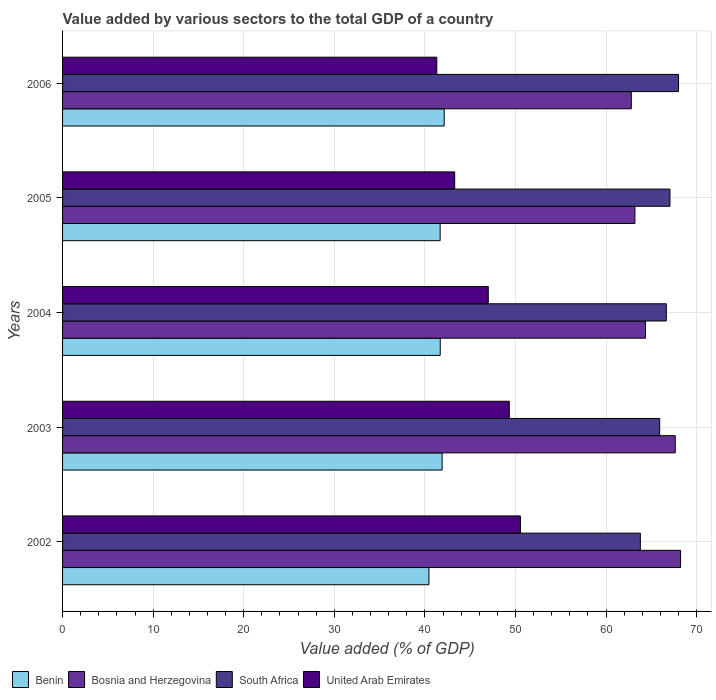How many groups of bars are there?
Offer a terse response. 5. Are the number of bars per tick equal to the number of legend labels?
Your answer should be very brief. Yes. How many bars are there on the 2nd tick from the top?
Provide a succinct answer. 4. In how many cases, is the number of bars for a given year not equal to the number of legend labels?
Provide a succinct answer. 0. What is the value added by various sectors to the total GDP in Benin in 2004?
Your response must be concise. 41.69. Across all years, what is the maximum value added by various sectors to the total GDP in Benin?
Give a very brief answer. 42.13. Across all years, what is the minimum value added by various sectors to the total GDP in United Arab Emirates?
Your answer should be compact. 41.32. In which year was the value added by various sectors to the total GDP in United Arab Emirates maximum?
Make the answer very short. 2002. In which year was the value added by various sectors to the total GDP in Bosnia and Herzegovina minimum?
Give a very brief answer. 2006. What is the total value added by various sectors to the total GDP in United Arab Emirates in the graph?
Make the answer very short. 231.48. What is the difference between the value added by various sectors to the total GDP in United Arab Emirates in 2002 and that in 2004?
Provide a short and direct response. 3.56. What is the difference between the value added by various sectors to the total GDP in Benin in 2006 and the value added by various sectors to the total GDP in Bosnia and Herzegovina in 2005?
Offer a very short reply. -21.05. What is the average value added by various sectors to the total GDP in United Arab Emirates per year?
Offer a terse response. 46.3. In the year 2005, what is the difference between the value added by various sectors to the total GDP in Bosnia and Herzegovina and value added by various sectors to the total GDP in South Africa?
Provide a succinct answer. -3.87. In how many years, is the value added by various sectors to the total GDP in Benin greater than 44 %?
Provide a succinct answer. 0. What is the ratio of the value added by various sectors to the total GDP in Benin in 2003 to that in 2006?
Your response must be concise. 0.99. Is the value added by various sectors to the total GDP in South Africa in 2002 less than that in 2004?
Your response must be concise. Yes. What is the difference between the highest and the second highest value added by various sectors to the total GDP in Benin?
Give a very brief answer. 0.23. What is the difference between the highest and the lowest value added by various sectors to the total GDP in Bosnia and Herzegovina?
Offer a very short reply. 5.44. In how many years, is the value added by various sectors to the total GDP in United Arab Emirates greater than the average value added by various sectors to the total GDP in United Arab Emirates taken over all years?
Provide a short and direct response. 3. What does the 1st bar from the top in 2004 represents?
Your response must be concise. United Arab Emirates. What does the 4th bar from the bottom in 2002 represents?
Offer a very short reply. United Arab Emirates. How many bars are there?
Keep it short and to the point. 20. Are all the bars in the graph horizontal?
Your response must be concise. Yes. How many years are there in the graph?
Provide a short and direct response. 5. What is the difference between two consecutive major ticks on the X-axis?
Make the answer very short. 10. Does the graph contain grids?
Give a very brief answer. Yes. Where does the legend appear in the graph?
Your answer should be compact. Bottom left. How many legend labels are there?
Offer a very short reply. 4. What is the title of the graph?
Offer a terse response. Value added by various sectors to the total GDP of a country. Does "Paraguay" appear as one of the legend labels in the graph?
Your response must be concise. No. What is the label or title of the X-axis?
Ensure brevity in your answer.  Value added (% of GDP). What is the label or title of the Y-axis?
Offer a very short reply. Years. What is the Value added (% of GDP) of Benin in 2002?
Ensure brevity in your answer.  40.45. What is the Value added (% of GDP) in Bosnia and Herzegovina in 2002?
Provide a succinct answer. 68.23. What is the Value added (% of GDP) of South Africa in 2002?
Provide a succinct answer. 63.79. What is the Value added (% of GDP) in United Arab Emirates in 2002?
Offer a terse response. 50.56. What is the Value added (% of GDP) in Benin in 2003?
Your answer should be compact. 41.9. What is the Value added (% of GDP) in Bosnia and Herzegovina in 2003?
Ensure brevity in your answer.  67.64. What is the Value added (% of GDP) in South Africa in 2003?
Make the answer very short. 65.92. What is the Value added (% of GDP) in United Arab Emirates in 2003?
Offer a terse response. 49.32. What is the Value added (% of GDP) in Benin in 2004?
Your answer should be very brief. 41.69. What is the Value added (% of GDP) of Bosnia and Herzegovina in 2004?
Provide a succinct answer. 64.35. What is the Value added (% of GDP) of South Africa in 2004?
Your answer should be compact. 66.66. What is the Value added (% of GDP) of United Arab Emirates in 2004?
Offer a very short reply. 47. What is the Value added (% of GDP) of Benin in 2005?
Provide a succinct answer. 41.68. What is the Value added (% of GDP) in Bosnia and Herzegovina in 2005?
Your answer should be compact. 63.19. What is the Value added (% of GDP) in South Africa in 2005?
Ensure brevity in your answer.  67.06. What is the Value added (% of GDP) of United Arab Emirates in 2005?
Give a very brief answer. 43.29. What is the Value added (% of GDP) of Benin in 2006?
Provide a short and direct response. 42.13. What is the Value added (% of GDP) of Bosnia and Herzegovina in 2006?
Ensure brevity in your answer.  62.79. What is the Value added (% of GDP) of South Africa in 2006?
Your answer should be compact. 68. What is the Value added (% of GDP) of United Arab Emirates in 2006?
Your answer should be very brief. 41.32. Across all years, what is the maximum Value added (% of GDP) of Benin?
Provide a succinct answer. 42.13. Across all years, what is the maximum Value added (% of GDP) in Bosnia and Herzegovina?
Ensure brevity in your answer.  68.23. Across all years, what is the maximum Value added (% of GDP) in South Africa?
Provide a short and direct response. 68. Across all years, what is the maximum Value added (% of GDP) in United Arab Emirates?
Offer a very short reply. 50.56. Across all years, what is the minimum Value added (% of GDP) in Benin?
Provide a short and direct response. 40.45. Across all years, what is the minimum Value added (% of GDP) in Bosnia and Herzegovina?
Your answer should be very brief. 62.79. Across all years, what is the minimum Value added (% of GDP) of South Africa?
Ensure brevity in your answer.  63.79. Across all years, what is the minimum Value added (% of GDP) of United Arab Emirates?
Your answer should be compact. 41.32. What is the total Value added (% of GDP) of Benin in the graph?
Keep it short and to the point. 207.86. What is the total Value added (% of GDP) in Bosnia and Herzegovina in the graph?
Provide a succinct answer. 326.2. What is the total Value added (% of GDP) in South Africa in the graph?
Keep it short and to the point. 331.43. What is the total Value added (% of GDP) in United Arab Emirates in the graph?
Your answer should be compact. 231.48. What is the difference between the Value added (% of GDP) in Benin in 2002 and that in 2003?
Your answer should be compact. -1.46. What is the difference between the Value added (% of GDP) of Bosnia and Herzegovina in 2002 and that in 2003?
Provide a succinct answer. 0.59. What is the difference between the Value added (% of GDP) in South Africa in 2002 and that in 2003?
Offer a very short reply. -2.14. What is the difference between the Value added (% of GDP) of United Arab Emirates in 2002 and that in 2003?
Your response must be concise. 1.24. What is the difference between the Value added (% of GDP) of Benin in 2002 and that in 2004?
Provide a short and direct response. -1.25. What is the difference between the Value added (% of GDP) in Bosnia and Herzegovina in 2002 and that in 2004?
Provide a short and direct response. 3.88. What is the difference between the Value added (% of GDP) of South Africa in 2002 and that in 2004?
Keep it short and to the point. -2.87. What is the difference between the Value added (% of GDP) in United Arab Emirates in 2002 and that in 2004?
Your answer should be very brief. 3.56. What is the difference between the Value added (% of GDP) in Benin in 2002 and that in 2005?
Your answer should be very brief. -1.24. What is the difference between the Value added (% of GDP) in Bosnia and Herzegovina in 2002 and that in 2005?
Keep it short and to the point. 5.04. What is the difference between the Value added (% of GDP) of South Africa in 2002 and that in 2005?
Make the answer very short. -3.27. What is the difference between the Value added (% of GDP) in United Arab Emirates in 2002 and that in 2005?
Your answer should be compact. 7.26. What is the difference between the Value added (% of GDP) in Benin in 2002 and that in 2006?
Offer a very short reply. -1.69. What is the difference between the Value added (% of GDP) in Bosnia and Herzegovina in 2002 and that in 2006?
Keep it short and to the point. 5.44. What is the difference between the Value added (% of GDP) of South Africa in 2002 and that in 2006?
Make the answer very short. -4.22. What is the difference between the Value added (% of GDP) in United Arab Emirates in 2002 and that in 2006?
Provide a short and direct response. 9.24. What is the difference between the Value added (% of GDP) of Benin in 2003 and that in 2004?
Your answer should be very brief. 0.21. What is the difference between the Value added (% of GDP) in Bosnia and Herzegovina in 2003 and that in 2004?
Provide a succinct answer. 3.29. What is the difference between the Value added (% of GDP) in South Africa in 2003 and that in 2004?
Your response must be concise. -0.73. What is the difference between the Value added (% of GDP) of United Arab Emirates in 2003 and that in 2004?
Give a very brief answer. 2.32. What is the difference between the Value added (% of GDP) of Benin in 2003 and that in 2005?
Your answer should be very brief. 0.22. What is the difference between the Value added (% of GDP) in Bosnia and Herzegovina in 2003 and that in 2005?
Your response must be concise. 4.46. What is the difference between the Value added (% of GDP) in South Africa in 2003 and that in 2005?
Give a very brief answer. -1.13. What is the difference between the Value added (% of GDP) in United Arab Emirates in 2003 and that in 2005?
Offer a very short reply. 6.03. What is the difference between the Value added (% of GDP) in Benin in 2003 and that in 2006?
Offer a very short reply. -0.23. What is the difference between the Value added (% of GDP) in Bosnia and Herzegovina in 2003 and that in 2006?
Ensure brevity in your answer.  4.85. What is the difference between the Value added (% of GDP) of South Africa in 2003 and that in 2006?
Offer a very short reply. -2.08. What is the difference between the Value added (% of GDP) in United Arab Emirates in 2003 and that in 2006?
Give a very brief answer. 8. What is the difference between the Value added (% of GDP) of Benin in 2004 and that in 2005?
Provide a short and direct response. 0.01. What is the difference between the Value added (% of GDP) in Bosnia and Herzegovina in 2004 and that in 2005?
Keep it short and to the point. 1.17. What is the difference between the Value added (% of GDP) in South Africa in 2004 and that in 2005?
Ensure brevity in your answer.  -0.4. What is the difference between the Value added (% of GDP) in United Arab Emirates in 2004 and that in 2005?
Offer a very short reply. 3.71. What is the difference between the Value added (% of GDP) of Benin in 2004 and that in 2006?
Offer a very short reply. -0.44. What is the difference between the Value added (% of GDP) of Bosnia and Herzegovina in 2004 and that in 2006?
Ensure brevity in your answer.  1.57. What is the difference between the Value added (% of GDP) of South Africa in 2004 and that in 2006?
Offer a terse response. -1.35. What is the difference between the Value added (% of GDP) of United Arab Emirates in 2004 and that in 2006?
Provide a succinct answer. 5.68. What is the difference between the Value added (% of GDP) in Benin in 2005 and that in 2006?
Your response must be concise. -0.45. What is the difference between the Value added (% of GDP) of Bosnia and Herzegovina in 2005 and that in 2006?
Make the answer very short. 0.4. What is the difference between the Value added (% of GDP) of South Africa in 2005 and that in 2006?
Your answer should be very brief. -0.95. What is the difference between the Value added (% of GDP) of United Arab Emirates in 2005 and that in 2006?
Your answer should be very brief. 1.98. What is the difference between the Value added (% of GDP) in Benin in 2002 and the Value added (% of GDP) in Bosnia and Herzegovina in 2003?
Provide a short and direct response. -27.2. What is the difference between the Value added (% of GDP) of Benin in 2002 and the Value added (% of GDP) of South Africa in 2003?
Your answer should be compact. -25.48. What is the difference between the Value added (% of GDP) in Benin in 2002 and the Value added (% of GDP) in United Arab Emirates in 2003?
Your response must be concise. -8.87. What is the difference between the Value added (% of GDP) in Bosnia and Herzegovina in 2002 and the Value added (% of GDP) in South Africa in 2003?
Make the answer very short. 2.31. What is the difference between the Value added (% of GDP) in Bosnia and Herzegovina in 2002 and the Value added (% of GDP) in United Arab Emirates in 2003?
Provide a succinct answer. 18.91. What is the difference between the Value added (% of GDP) of South Africa in 2002 and the Value added (% of GDP) of United Arab Emirates in 2003?
Provide a succinct answer. 14.47. What is the difference between the Value added (% of GDP) in Benin in 2002 and the Value added (% of GDP) in Bosnia and Herzegovina in 2004?
Your answer should be compact. -23.91. What is the difference between the Value added (% of GDP) of Benin in 2002 and the Value added (% of GDP) of South Africa in 2004?
Your answer should be very brief. -26.21. What is the difference between the Value added (% of GDP) of Benin in 2002 and the Value added (% of GDP) of United Arab Emirates in 2004?
Your response must be concise. -6.55. What is the difference between the Value added (% of GDP) of Bosnia and Herzegovina in 2002 and the Value added (% of GDP) of South Africa in 2004?
Provide a succinct answer. 1.57. What is the difference between the Value added (% of GDP) of Bosnia and Herzegovina in 2002 and the Value added (% of GDP) of United Arab Emirates in 2004?
Your answer should be very brief. 21.23. What is the difference between the Value added (% of GDP) of South Africa in 2002 and the Value added (% of GDP) of United Arab Emirates in 2004?
Offer a terse response. 16.79. What is the difference between the Value added (% of GDP) of Benin in 2002 and the Value added (% of GDP) of Bosnia and Herzegovina in 2005?
Offer a terse response. -22.74. What is the difference between the Value added (% of GDP) in Benin in 2002 and the Value added (% of GDP) in South Africa in 2005?
Offer a very short reply. -26.61. What is the difference between the Value added (% of GDP) of Benin in 2002 and the Value added (% of GDP) of United Arab Emirates in 2005?
Give a very brief answer. -2.85. What is the difference between the Value added (% of GDP) in Bosnia and Herzegovina in 2002 and the Value added (% of GDP) in South Africa in 2005?
Provide a succinct answer. 1.17. What is the difference between the Value added (% of GDP) of Bosnia and Herzegovina in 2002 and the Value added (% of GDP) of United Arab Emirates in 2005?
Provide a succinct answer. 24.94. What is the difference between the Value added (% of GDP) of South Africa in 2002 and the Value added (% of GDP) of United Arab Emirates in 2005?
Make the answer very short. 20.5. What is the difference between the Value added (% of GDP) of Benin in 2002 and the Value added (% of GDP) of Bosnia and Herzegovina in 2006?
Offer a very short reply. -22.34. What is the difference between the Value added (% of GDP) in Benin in 2002 and the Value added (% of GDP) in South Africa in 2006?
Your answer should be compact. -27.56. What is the difference between the Value added (% of GDP) of Benin in 2002 and the Value added (% of GDP) of United Arab Emirates in 2006?
Keep it short and to the point. -0.87. What is the difference between the Value added (% of GDP) in Bosnia and Herzegovina in 2002 and the Value added (% of GDP) in South Africa in 2006?
Offer a very short reply. 0.23. What is the difference between the Value added (% of GDP) of Bosnia and Herzegovina in 2002 and the Value added (% of GDP) of United Arab Emirates in 2006?
Your response must be concise. 26.91. What is the difference between the Value added (% of GDP) of South Africa in 2002 and the Value added (% of GDP) of United Arab Emirates in 2006?
Keep it short and to the point. 22.47. What is the difference between the Value added (% of GDP) of Benin in 2003 and the Value added (% of GDP) of Bosnia and Herzegovina in 2004?
Your answer should be compact. -22.45. What is the difference between the Value added (% of GDP) of Benin in 2003 and the Value added (% of GDP) of South Africa in 2004?
Offer a very short reply. -24.75. What is the difference between the Value added (% of GDP) in Benin in 2003 and the Value added (% of GDP) in United Arab Emirates in 2004?
Your response must be concise. -5.09. What is the difference between the Value added (% of GDP) of Bosnia and Herzegovina in 2003 and the Value added (% of GDP) of South Africa in 2004?
Give a very brief answer. 0.99. What is the difference between the Value added (% of GDP) in Bosnia and Herzegovina in 2003 and the Value added (% of GDP) in United Arab Emirates in 2004?
Keep it short and to the point. 20.65. What is the difference between the Value added (% of GDP) of South Africa in 2003 and the Value added (% of GDP) of United Arab Emirates in 2004?
Your answer should be very brief. 18.93. What is the difference between the Value added (% of GDP) in Benin in 2003 and the Value added (% of GDP) in Bosnia and Herzegovina in 2005?
Your response must be concise. -21.28. What is the difference between the Value added (% of GDP) of Benin in 2003 and the Value added (% of GDP) of South Africa in 2005?
Your answer should be very brief. -25.15. What is the difference between the Value added (% of GDP) in Benin in 2003 and the Value added (% of GDP) in United Arab Emirates in 2005?
Your answer should be compact. -1.39. What is the difference between the Value added (% of GDP) in Bosnia and Herzegovina in 2003 and the Value added (% of GDP) in South Africa in 2005?
Make the answer very short. 0.59. What is the difference between the Value added (% of GDP) of Bosnia and Herzegovina in 2003 and the Value added (% of GDP) of United Arab Emirates in 2005?
Your response must be concise. 24.35. What is the difference between the Value added (% of GDP) of South Africa in 2003 and the Value added (% of GDP) of United Arab Emirates in 2005?
Make the answer very short. 22.63. What is the difference between the Value added (% of GDP) in Benin in 2003 and the Value added (% of GDP) in Bosnia and Herzegovina in 2006?
Give a very brief answer. -20.88. What is the difference between the Value added (% of GDP) in Benin in 2003 and the Value added (% of GDP) in South Africa in 2006?
Offer a very short reply. -26.1. What is the difference between the Value added (% of GDP) in Benin in 2003 and the Value added (% of GDP) in United Arab Emirates in 2006?
Give a very brief answer. 0.59. What is the difference between the Value added (% of GDP) of Bosnia and Herzegovina in 2003 and the Value added (% of GDP) of South Africa in 2006?
Provide a succinct answer. -0.36. What is the difference between the Value added (% of GDP) in Bosnia and Herzegovina in 2003 and the Value added (% of GDP) in United Arab Emirates in 2006?
Offer a very short reply. 26.33. What is the difference between the Value added (% of GDP) in South Africa in 2003 and the Value added (% of GDP) in United Arab Emirates in 2006?
Keep it short and to the point. 24.61. What is the difference between the Value added (% of GDP) in Benin in 2004 and the Value added (% of GDP) in Bosnia and Herzegovina in 2005?
Give a very brief answer. -21.49. What is the difference between the Value added (% of GDP) in Benin in 2004 and the Value added (% of GDP) in South Africa in 2005?
Provide a short and direct response. -25.36. What is the difference between the Value added (% of GDP) of Benin in 2004 and the Value added (% of GDP) of United Arab Emirates in 2005?
Keep it short and to the point. -1.6. What is the difference between the Value added (% of GDP) in Bosnia and Herzegovina in 2004 and the Value added (% of GDP) in South Africa in 2005?
Provide a short and direct response. -2.7. What is the difference between the Value added (% of GDP) of Bosnia and Herzegovina in 2004 and the Value added (% of GDP) of United Arab Emirates in 2005?
Give a very brief answer. 21.06. What is the difference between the Value added (% of GDP) in South Africa in 2004 and the Value added (% of GDP) in United Arab Emirates in 2005?
Provide a short and direct response. 23.36. What is the difference between the Value added (% of GDP) in Benin in 2004 and the Value added (% of GDP) in Bosnia and Herzegovina in 2006?
Offer a terse response. -21.09. What is the difference between the Value added (% of GDP) of Benin in 2004 and the Value added (% of GDP) of South Africa in 2006?
Your answer should be compact. -26.31. What is the difference between the Value added (% of GDP) of Benin in 2004 and the Value added (% of GDP) of United Arab Emirates in 2006?
Provide a succinct answer. 0.38. What is the difference between the Value added (% of GDP) of Bosnia and Herzegovina in 2004 and the Value added (% of GDP) of South Africa in 2006?
Offer a terse response. -3.65. What is the difference between the Value added (% of GDP) of Bosnia and Herzegovina in 2004 and the Value added (% of GDP) of United Arab Emirates in 2006?
Ensure brevity in your answer.  23.04. What is the difference between the Value added (% of GDP) of South Africa in 2004 and the Value added (% of GDP) of United Arab Emirates in 2006?
Offer a terse response. 25.34. What is the difference between the Value added (% of GDP) in Benin in 2005 and the Value added (% of GDP) in Bosnia and Herzegovina in 2006?
Give a very brief answer. -21.11. What is the difference between the Value added (% of GDP) of Benin in 2005 and the Value added (% of GDP) of South Africa in 2006?
Provide a short and direct response. -26.32. What is the difference between the Value added (% of GDP) in Benin in 2005 and the Value added (% of GDP) in United Arab Emirates in 2006?
Provide a short and direct response. 0.37. What is the difference between the Value added (% of GDP) of Bosnia and Herzegovina in 2005 and the Value added (% of GDP) of South Africa in 2006?
Keep it short and to the point. -4.82. What is the difference between the Value added (% of GDP) in Bosnia and Herzegovina in 2005 and the Value added (% of GDP) in United Arab Emirates in 2006?
Make the answer very short. 21.87. What is the difference between the Value added (% of GDP) in South Africa in 2005 and the Value added (% of GDP) in United Arab Emirates in 2006?
Provide a short and direct response. 25.74. What is the average Value added (% of GDP) in Benin per year?
Offer a terse response. 41.57. What is the average Value added (% of GDP) in Bosnia and Herzegovina per year?
Offer a terse response. 65.24. What is the average Value added (% of GDP) of South Africa per year?
Provide a succinct answer. 66.29. What is the average Value added (% of GDP) in United Arab Emirates per year?
Provide a succinct answer. 46.3. In the year 2002, what is the difference between the Value added (% of GDP) in Benin and Value added (% of GDP) in Bosnia and Herzegovina?
Your answer should be compact. -27.78. In the year 2002, what is the difference between the Value added (% of GDP) of Benin and Value added (% of GDP) of South Africa?
Provide a succinct answer. -23.34. In the year 2002, what is the difference between the Value added (% of GDP) in Benin and Value added (% of GDP) in United Arab Emirates?
Offer a terse response. -10.11. In the year 2002, what is the difference between the Value added (% of GDP) in Bosnia and Herzegovina and Value added (% of GDP) in South Africa?
Ensure brevity in your answer.  4.44. In the year 2002, what is the difference between the Value added (% of GDP) in Bosnia and Herzegovina and Value added (% of GDP) in United Arab Emirates?
Keep it short and to the point. 17.67. In the year 2002, what is the difference between the Value added (% of GDP) in South Africa and Value added (% of GDP) in United Arab Emirates?
Ensure brevity in your answer.  13.23. In the year 2003, what is the difference between the Value added (% of GDP) of Benin and Value added (% of GDP) of Bosnia and Herzegovina?
Your answer should be compact. -25.74. In the year 2003, what is the difference between the Value added (% of GDP) in Benin and Value added (% of GDP) in South Africa?
Offer a very short reply. -24.02. In the year 2003, what is the difference between the Value added (% of GDP) of Benin and Value added (% of GDP) of United Arab Emirates?
Your answer should be compact. -7.41. In the year 2003, what is the difference between the Value added (% of GDP) in Bosnia and Herzegovina and Value added (% of GDP) in South Africa?
Your response must be concise. 1.72. In the year 2003, what is the difference between the Value added (% of GDP) of Bosnia and Herzegovina and Value added (% of GDP) of United Arab Emirates?
Ensure brevity in your answer.  18.32. In the year 2003, what is the difference between the Value added (% of GDP) in South Africa and Value added (% of GDP) in United Arab Emirates?
Offer a terse response. 16.6. In the year 2004, what is the difference between the Value added (% of GDP) in Benin and Value added (% of GDP) in Bosnia and Herzegovina?
Provide a short and direct response. -22.66. In the year 2004, what is the difference between the Value added (% of GDP) of Benin and Value added (% of GDP) of South Africa?
Ensure brevity in your answer.  -24.96. In the year 2004, what is the difference between the Value added (% of GDP) in Benin and Value added (% of GDP) in United Arab Emirates?
Provide a short and direct response. -5.3. In the year 2004, what is the difference between the Value added (% of GDP) of Bosnia and Herzegovina and Value added (% of GDP) of South Africa?
Ensure brevity in your answer.  -2.3. In the year 2004, what is the difference between the Value added (% of GDP) of Bosnia and Herzegovina and Value added (% of GDP) of United Arab Emirates?
Provide a short and direct response. 17.36. In the year 2004, what is the difference between the Value added (% of GDP) of South Africa and Value added (% of GDP) of United Arab Emirates?
Offer a very short reply. 19.66. In the year 2005, what is the difference between the Value added (% of GDP) in Benin and Value added (% of GDP) in Bosnia and Herzegovina?
Your response must be concise. -21.5. In the year 2005, what is the difference between the Value added (% of GDP) in Benin and Value added (% of GDP) in South Africa?
Provide a short and direct response. -25.37. In the year 2005, what is the difference between the Value added (% of GDP) in Benin and Value added (% of GDP) in United Arab Emirates?
Make the answer very short. -1.61. In the year 2005, what is the difference between the Value added (% of GDP) in Bosnia and Herzegovina and Value added (% of GDP) in South Africa?
Make the answer very short. -3.87. In the year 2005, what is the difference between the Value added (% of GDP) of Bosnia and Herzegovina and Value added (% of GDP) of United Arab Emirates?
Provide a succinct answer. 19.89. In the year 2005, what is the difference between the Value added (% of GDP) of South Africa and Value added (% of GDP) of United Arab Emirates?
Provide a short and direct response. 23.76. In the year 2006, what is the difference between the Value added (% of GDP) of Benin and Value added (% of GDP) of Bosnia and Herzegovina?
Provide a short and direct response. -20.66. In the year 2006, what is the difference between the Value added (% of GDP) of Benin and Value added (% of GDP) of South Africa?
Give a very brief answer. -25.87. In the year 2006, what is the difference between the Value added (% of GDP) in Benin and Value added (% of GDP) in United Arab Emirates?
Offer a terse response. 0.82. In the year 2006, what is the difference between the Value added (% of GDP) in Bosnia and Herzegovina and Value added (% of GDP) in South Africa?
Offer a very short reply. -5.21. In the year 2006, what is the difference between the Value added (% of GDP) of Bosnia and Herzegovina and Value added (% of GDP) of United Arab Emirates?
Ensure brevity in your answer.  21.47. In the year 2006, what is the difference between the Value added (% of GDP) in South Africa and Value added (% of GDP) in United Arab Emirates?
Keep it short and to the point. 26.69. What is the ratio of the Value added (% of GDP) in Benin in 2002 to that in 2003?
Your response must be concise. 0.97. What is the ratio of the Value added (% of GDP) in Bosnia and Herzegovina in 2002 to that in 2003?
Offer a terse response. 1.01. What is the ratio of the Value added (% of GDP) in South Africa in 2002 to that in 2003?
Offer a terse response. 0.97. What is the ratio of the Value added (% of GDP) of United Arab Emirates in 2002 to that in 2003?
Provide a short and direct response. 1.03. What is the ratio of the Value added (% of GDP) of Benin in 2002 to that in 2004?
Your answer should be very brief. 0.97. What is the ratio of the Value added (% of GDP) of Bosnia and Herzegovina in 2002 to that in 2004?
Ensure brevity in your answer.  1.06. What is the ratio of the Value added (% of GDP) in South Africa in 2002 to that in 2004?
Make the answer very short. 0.96. What is the ratio of the Value added (% of GDP) of United Arab Emirates in 2002 to that in 2004?
Give a very brief answer. 1.08. What is the ratio of the Value added (% of GDP) in Benin in 2002 to that in 2005?
Your answer should be compact. 0.97. What is the ratio of the Value added (% of GDP) of Bosnia and Herzegovina in 2002 to that in 2005?
Ensure brevity in your answer.  1.08. What is the ratio of the Value added (% of GDP) of South Africa in 2002 to that in 2005?
Offer a very short reply. 0.95. What is the ratio of the Value added (% of GDP) of United Arab Emirates in 2002 to that in 2005?
Make the answer very short. 1.17. What is the ratio of the Value added (% of GDP) of Benin in 2002 to that in 2006?
Offer a very short reply. 0.96. What is the ratio of the Value added (% of GDP) of Bosnia and Herzegovina in 2002 to that in 2006?
Offer a very short reply. 1.09. What is the ratio of the Value added (% of GDP) of South Africa in 2002 to that in 2006?
Offer a terse response. 0.94. What is the ratio of the Value added (% of GDP) of United Arab Emirates in 2002 to that in 2006?
Your answer should be very brief. 1.22. What is the ratio of the Value added (% of GDP) of Bosnia and Herzegovina in 2003 to that in 2004?
Your response must be concise. 1.05. What is the ratio of the Value added (% of GDP) of South Africa in 2003 to that in 2004?
Offer a very short reply. 0.99. What is the ratio of the Value added (% of GDP) in United Arab Emirates in 2003 to that in 2004?
Your answer should be very brief. 1.05. What is the ratio of the Value added (% of GDP) of Benin in 2003 to that in 2005?
Keep it short and to the point. 1.01. What is the ratio of the Value added (% of GDP) of Bosnia and Herzegovina in 2003 to that in 2005?
Offer a very short reply. 1.07. What is the ratio of the Value added (% of GDP) in South Africa in 2003 to that in 2005?
Offer a very short reply. 0.98. What is the ratio of the Value added (% of GDP) of United Arab Emirates in 2003 to that in 2005?
Provide a short and direct response. 1.14. What is the ratio of the Value added (% of GDP) in Benin in 2003 to that in 2006?
Provide a succinct answer. 0.99. What is the ratio of the Value added (% of GDP) of Bosnia and Herzegovina in 2003 to that in 2006?
Ensure brevity in your answer.  1.08. What is the ratio of the Value added (% of GDP) in South Africa in 2003 to that in 2006?
Make the answer very short. 0.97. What is the ratio of the Value added (% of GDP) of United Arab Emirates in 2003 to that in 2006?
Make the answer very short. 1.19. What is the ratio of the Value added (% of GDP) in Bosnia and Herzegovina in 2004 to that in 2005?
Your response must be concise. 1.02. What is the ratio of the Value added (% of GDP) in South Africa in 2004 to that in 2005?
Your answer should be very brief. 0.99. What is the ratio of the Value added (% of GDP) of United Arab Emirates in 2004 to that in 2005?
Offer a terse response. 1.09. What is the ratio of the Value added (% of GDP) in Benin in 2004 to that in 2006?
Ensure brevity in your answer.  0.99. What is the ratio of the Value added (% of GDP) of Bosnia and Herzegovina in 2004 to that in 2006?
Offer a very short reply. 1.02. What is the ratio of the Value added (% of GDP) of South Africa in 2004 to that in 2006?
Provide a short and direct response. 0.98. What is the ratio of the Value added (% of GDP) in United Arab Emirates in 2004 to that in 2006?
Provide a succinct answer. 1.14. What is the ratio of the Value added (% of GDP) of Benin in 2005 to that in 2006?
Give a very brief answer. 0.99. What is the ratio of the Value added (% of GDP) in South Africa in 2005 to that in 2006?
Keep it short and to the point. 0.99. What is the ratio of the Value added (% of GDP) of United Arab Emirates in 2005 to that in 2006?
Your answer should be compact. 1.05. What is the difference between the highest and the second highest Value added (% of GDP) of Benin?
Keep it short and to the point. 0.23. What is the difference between the highest and the second highest Value added (% of GDP) of Bosnia and Herzegovina?
Provide a succinct answer. 0.59. What is the difference between the highest and the second highest Value added (% of GDP) in South Africa?
Offer a very short reply. 0.95. What is the difference between the highest and the second highest Value added (% of GDP) in United Arab Emirates?
Provide a short and direct response. 1.24. What is the difference between the highest and the lowest Value added (% of GDP) in Benin?
Offer a terse response. 1.69. What is the difference between the highest and the lowest Value added (% of GDP) of Bosnia and Herzegovina?
Offer a very short reply. 5.44. What is the difference between the highest and the lowest Value added (% of GDP) of South Africa?
Provide a short and direct response. 4.22. What is the difference between the highest and the lowest Value added (% of GDP) in United Arab Emirates?
Make the answer very short. 9.24. 